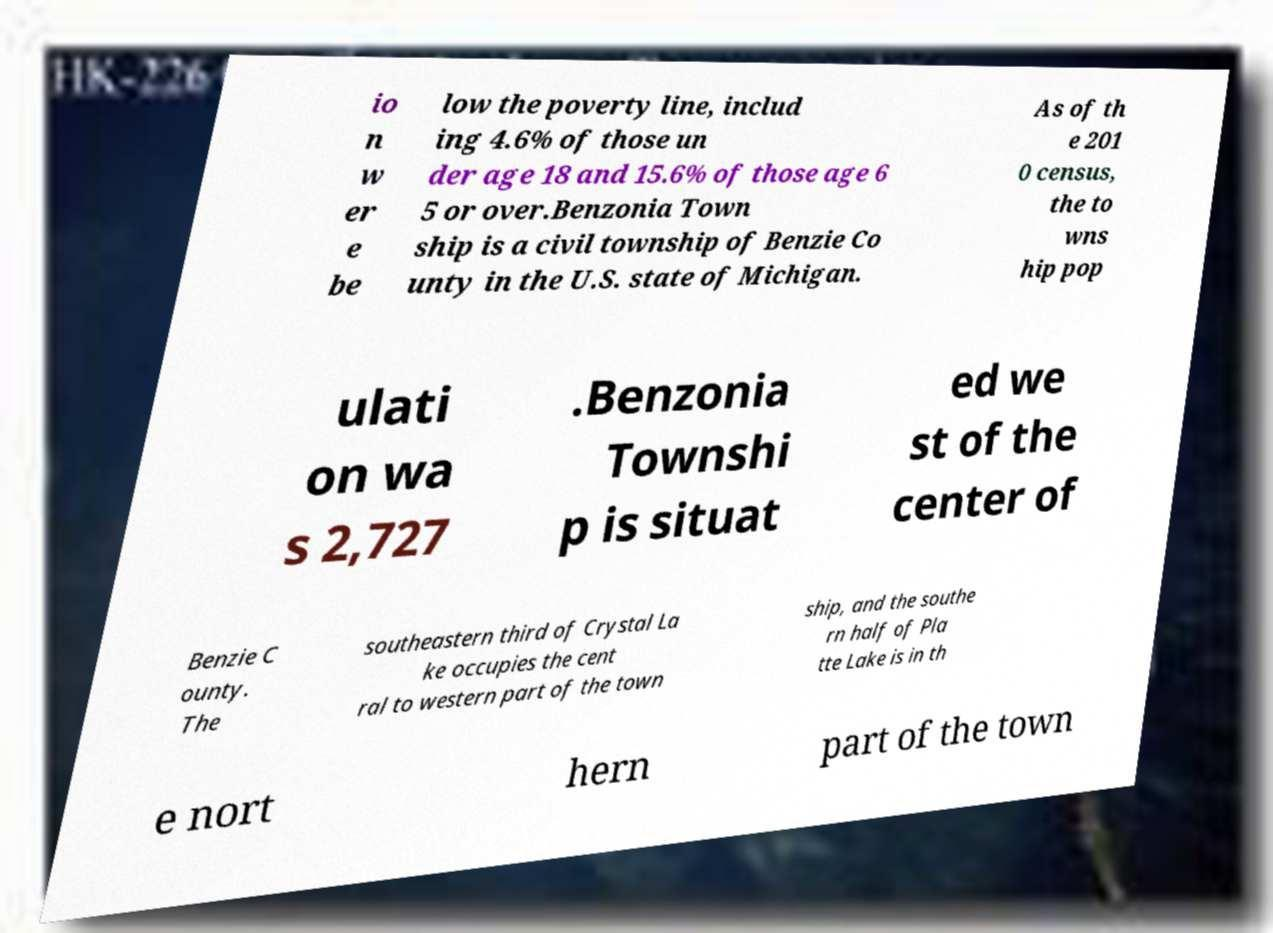Please identify and transcribe the text found in this image. io n w er e be low the poverty line, includ ing 4.6% of those un der age 18 and 15.6% of those age 6 5 or over.Benzonia Town ship is a civil township of Benzie Co unty in the U.S. state of Michigan. As of th e 201 0 census, the to wns hip pop ulati on wa s 2,727 .Benzonia Townshi p is situat ed we st of the center of Benzie C ounty. The southeastern third of Crystal La ke occupies the cent ral to western part of the town ship, and the southe rn half of Pla tte Lake is in th e nort hern part of the town 